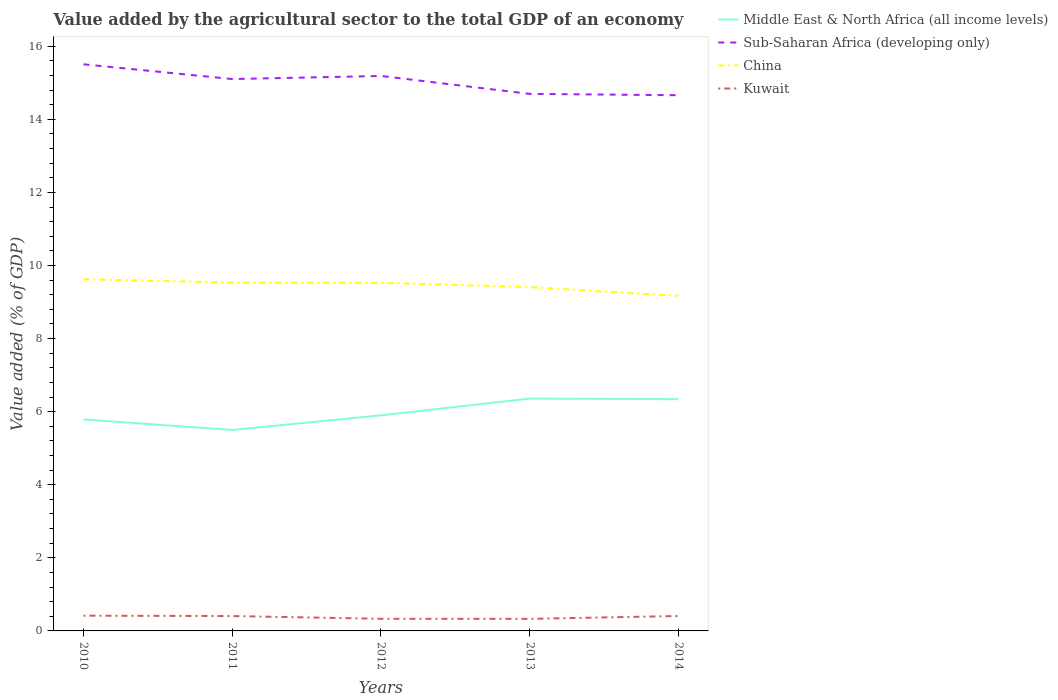Across all years, what is the maximum value added by the agricultural sector to the total GDP in Middle East & North Africa (all income levels)?
Your response must be concise. 5.5. In which year was the value added by the agricultural sector to the total GDP in Sub-Saharan Africa (developing only) maximum?
Make the answer very short. 2014. What is the total value added by the agricultural sector to the total GDP in China in the graph?
Your answer should be compact. 0.36. What is the difference between the highest and the second highest value added by the agricultural sector to the total GDP in Kuwait?
Your answer should be very brief. 0.09. What is the difference between two consecutive major ticks on the Y-axis?
Your answer should be compact. 2. Are the values on the major ticks of Y-axis written in scientific E-notation?
Give a very brief answer. No. How many legend labels are there?
Your answer should be compact. 4. What is the title of the graph?
Provide a succinct answer. Value added by the agricultural sector to the total GDP of an economy. Does "Middle East & North Africa (all income levels)" appear as one of the legend labels in the graph?
Ensure brevity in your answer.  Yes. What is the label or title of the Y-axis?
Make the answer very short. Value added (% of GDP). What is the Value added (% of GDP) of Middle East & North Africa (all income levels) in 2010?
Your answer should be compact. 5.79. What is the Value added (% of GDP) in Sub-Saharan Africa (developing only) in 2010?
Offer a very short reply. 15.51. What is the Value added (% of GDP) of China in 2010?
Offer a terse response. 9.62. What is the Value added (% of GDP) in Kuwait in 2010?
Give a very brief answer. 0.42. What is the Value added (% of GDP) of Middle East & North Africa (all income levels) in 2011?
Your answer should be very brief. 5.5. What is the Value added (% of GDP) of Sub-Saharan Africa (developing only) in 2011?
Offer a very short reply. 15.1. What is the Value added (% of GDP) in China in 2011?
Keep it short and to the point. 9.53. What is the Value added (% of GDP) of Kuwait in 2011?
Your response must be concise. 0.41. What is the Value added (% of GDP) of Middle East & North Africa (all income levels) in 2012?
Offer a terse response. 5.9. What is the Value added (% of GDP) of Sub-Saharan Africa (developing only) in 2012?
Provide a short and direct response. 15.19. What is the Value added (% of GDP) in China in 2012?
Your answer should be compact. 9.53. What is the Value added (% of GDP) of Kuwait in 2012?
Make the answer very short. 0.33. What is the Value added (% of GDP) in Middle East & North Africa (all income levels) in 2013?
Ensure brevity in your answer.  6.36. What is the Value added (% of GDP) in Sub-Saharan Africa (developing only) in 2013?
Provide a succinct answer. 14.7. What is the Value added (% of GDP) in China in 2013?
Your answer should be compact. 9.41. What is the Value added (% of GDP) in Kuwait in 2013?
Offer a very short reply. 0.33. What is the Value added (% of GDP) of Middle East & North Africa (all income levels) in 2014?
Provide a short and direct response. 6.34. What is the Value added (% of GDP) of Sub-Saharan Africa (developing only) in 2014?
Provide a succinct answer. 14.66. What is the Value added (% of GDP) of China in 2014?
Provide a short and direct response. 9.17. What is the Value added (% of GDP) in Kuwait in 2014?
Ensure brevity in your answer.  0.41. Across all years, what is the maximum Value added (% of GDP) in Middle East & North Africa (all income levels)?
Your answer should be very brief. 6.36. Across all years, what is the maximum Value added (% of GDP) in Sub-Saharan Africa (developing only)?
Give a very brief answer. 15.51. Across all years, what is the maximum Value added (% of GDP) of China?
Your answer should be very brief. 9.62. Across all years, what is the maximum Value added (% of GDP) in Kuwait?
Make the answer very short. 0.42. Across all years, what is the minimum Value added (% of GDP) of Middle East & North Africa (all income levels)?
Make the answer very short. 5.5. Across all years, what is the minimum Value added (% of GDP) of Sub-Saharan Africa (developing only)?
Your answer should be very brief. 14.66. Across all years, what is the minimum Value added (% of GDP) of China?
Offer a very short reply. 9.17. Across all years, what is the minimum Value added (% of GDP) in Kuwait?
Make the answer very short. 0.33. What is the total Value added (% of GDP) of Middle East & North Africa (all income levels) in the graph?
Give a very brief answer. 29.89. What is the total Value added (% of GDP) of Sub-Saharan Africa (developing only) in the graph?
Your response must be concise. 75.15. What is the total Value added (% of GDP) of China in the graph?
Give a very brief answer. 47.26. What is the total Value added (% of GDP) of Kuwait in the graph?
Provide a succinct answer. 1.89. What is the difference between the Value added (% of GDP) in Middle East & North Africa (all income levels) in 2010 and that in 2011?
Offer a terse response. 0.29. What is the difference between the Value added (% of GDP) in Sub-Saharan Africa (developing only) in 2010 and that in 2011?
Give a very brief answer. 0.4. What is the difference between the Value added (% of GDP) of China in 2010 and that in 2011?
Offer a terse response. 0.09. What is the difference between the Value added (% of GDP) of Kuwait in 2010 and that in 2011?
Your response must be concise. 0.01. What is the difference between the Value added (% of GDP) of Middle East & North Africa (all income levels) in 2010 and that in 2012?
Your answer should be compact. -0.11. What is the difference between the Value added (% of GDP) of Sub-Saharan Africa (developing only) in 2010 and that in 2012?
Keep it short and to the point. 0.32. What is the difference between the Value added (% of GDP) in China in 2010 and that in 2012?
Make the answer very short. 0.1. What is the difference between the Value added (% of GDP) of Kuwait in 2010 and that in 2012?
Your response must be concise. 0.09. What is the difference between the Value added (% of GDP) in Middle East & North Africa (all income levels) in 2010 and that in 2013?
Your response must be concise. -0.57. What is the difference between the Value added (% of GDP) of Sub-Saharan Africa (developing only) in 2010 and that in 2013?
Ensure brevity in your answer.  0.81. What is the difference between the Value added (% of GDP) in China in 2010 and that in 2013?
Give a very brief answer. 0.22. What is the difference between the Value added (% of GDP) of Kuwait in 2010 and that in 2013?
Make the answer very short. 0.09. What is the difference between the Value added (% of GDP) in Middle East & North Africa (all income levels) in 2010 and that in 2014?
Give a very brief answer. -0.55. What is the difference between the Value added (% of GDP) of Sub-Saharan Africa (developing only) in 2010 and that in 2014?
Your response must be concise. 0.85. What is the difference between the Value added (% of GDP) in China in 2010 and that in 2014?
Make the answer very short. 0.45. What is the difference between the Value added (% of GDP) in Kuwait in 2010 and that in 2014?
Give a very brief answer. 0.01. What is the difference between the Value added (% of GDP) in Middle East & North Africa (all income levels) in 2011 and that in 2012?
Provide a short and direct response. -0.4. What is the difference between the Value added (% of GDP) of Sub-Saharan Africa (developing only) in 2011 and that in 2012?
Offer a terse response. -0.08. What is the difference between the Value added (% of GDP) of China in 2011 and that in 2012?
Give a very brief answer. 0.01. What is the difference between the Value added (% of GDP) in Kuwait in 2011 and that in 2012?
Your response must be concise. 0.07. What is the difference between the Value added (% of GDP) of Middle East & North Africa (all income levels) in 2011 and that in 2013?
Provide a short and direct response. -0.86. What is the difference between the Value added (% of GDP) of Sub-Saharan Africa (developing only) in 2011 and that in 2013?
Keep it short and to the point. 0.41. What is the difference between the Value added (% of GDP) of China in 2011 and that in 2013?
Your answer should be very brief. 0.13. What is the difference between the Value added (% of GDP) in Kuwait in 2011 and that in 2013?
Your answer should be very brief. 0.08. What is the difference between the Value added (% of GDP) of Middle East & North Africa (all income levels) in 2011 and that in 2014?
Your answer should be compact. -0.84. What is the difference between the Value added (% of GDP) in Sub-Saharan Africa (developing only) in 2011 and that in 2014?
Offer a terse response. 0.44. What is the difference between the Value added (% of GDP) in China in 2011 and that in 2014?
Provide a short and direct response. 0.36. What is the difference between the Value added (% of GDP) in Kuwait in 2011 and that in 2014?
Ensure brevity in your answer.  -0. What is the difference between the Value added (% of GDP) of Middle East & North Africa (all income levels) in 2012 and that in 2013?
Keep it short and to the point. -0.46. What is the difference between the Value added (% of GDP) of Sub-Saharan Africa (developing only) in 2012 and that in 2013?
Your response must be concise. 0.49. What is the difference between the Value added (% of GDP) in China in 2012 and that in 2013?
Your answer should be compact. 0.12. What is the difference between the Value added (% of GDP) of Kuwait in 2012 and that in 2013?
Provide a short and direct response. 0. What is the difference between the Value added (% of GDP) of Middle East & North Africa (all income levels) in 2012 and that in 2014?
Offer a terse response. -0.44. What is the difference between the Value added (% of GDP) of Sub-Saharan Africa (developing only) in 2012 and that in 2014?
Provide a succinct answer. 0.53. What is the difference between the Value added (% of GDP) in China in 2012 and that in 2014?
Offer a terse response. 0.36. What is the difference between the Value added (% of GDP) of Kuwait in 2012 and that in 2014?
Keep it short and to the point. -0.08. What is the difference between the Value added (% of GDP) of Middle East & North Africa (all income levels) in 2013 and that in 2014?
Keep it short and to the point. 0.02. What is the difference between the Value added (% of GDP) in Sub-Saharan Africa (developing only) in 2013 and that in 2014?
Your answer should be compact. 0.04. What is the difference between the Value added (% of GDP) of China in 2013 and that in 2014?
Your answer should be very brief. 0.24. What is the difference between the Value added (% of GDP) in Kuwait in 2013 and that in 2014?
Your answer should be very brief. -0.08. What is the difference between the Value added (% of GDP) in Middle East & North Africa (all income levels) in 2010 and the Value added (% of GDP) in Sub-Saharan Africa (developing only) in 2011?
Offer a very short reply. -9.32. What is the difference between the Value added (% of GDP) in Middle East & North Africa (all income levels) in 2010 and the Value added (% of GDP) in China in 2011?
Make the answer very short. -3.75. What is the difference between the Value added (% of GDP) of Middle East & North Africa (all income levels) in 2010 and the Value added (% of GDP) of Kuwait in 2011?
Make the answer very short. 5.38. What is the difference between the Value added (% of GDP) in Sub-Saharan Africa (developing only) in 2010 and the Value added (% of GDP) in China in 2011?
Ensure brevity in your answer.  5.97. What is the difference between the Value added (% of GDP) of Sub-Saharan Africa (developing only) in 2010 and the Value added (% of GDP) of Kuwait in 2011?
Your answer should be very brief. 15.1. What is the difference between the Value added (% of GDP) in China in 2010 and the Value added (% of GDP) in Kuwait in 2011?
Your answer should be compact. 9.22. What is the difference between the Value added (% of GDP) in Middle East & North Africa (all income levels) in 2010 and the Value added (% of GDP) in Sub-Saharan Africa (developing only) in 2012?
Offer a terse response. -9.4. What is the difference between the Value added (% of GDP) of Middle East & North Africa (all income levels) in 2010 and the Value added (% of GDP) of China in 2012?
Ensure brevity in your answer.  -3.74. What is the difference between the Value added (% of GDP) of Middle East & North Africa (all income levels) in 2010 and the Value added (% of GDP) of Kuwait in 2012?
Your response must be concise. 5.46. What is the difference between the Value added (% of GDP) in Sub-Saharan Africa (developing only) in 2010 and the Value added (% of GDP) in China in 2012?
Keep it short and to the point. 5.98. What is the difference between the Value added (% of GDP) of Sub-Saharan Africa (developing only) in 2010 and the Value added (% of GDP) of Kuwait in 2012?
Your answer should be compact. 15.17. What is the difference between the Value added (% of GDP) in China in 2010 and the Value added (% of GDP) in Kuwait in 2012?
Provide a short and direct response. 9.29. What is the difference between the Value added (% of GDP) in Middle East & North Africa (all income levels) in 2010 and the Value added (% of GDP) in Sub-Saharan Africa (developing only) in 2013?
Your answer should be compact. -8.91. What is the difference between the Value added (% of GDP) of Middle East & North Africa (all income levels) in 2010 and the Value added (% of GDP) of China in 2013?
Give a very brief answer. -3.62. What is the difference between the Value added (% of GDP) of Middle East & North Africa (all income levels) in 2010 and the Value added (% of GDP) of Kuwait in 2013?
Give a very brief answer. 5.46. What is the difference between the Value added (% of GDP) of Sub-Saharan Africa (developing only) in 2010 and the Value added (% of GDP) of China in 2013?
Your answer should be very brief. 6.1. What is the difference between the Value added (% of GDP) in Sub-Saharan Africa (developing only) in 2010 and the Value added (% of GDP) in Kuwait in 2013?
Keep it short and to the point. 15.18. What is the difference between the Value added (% of GDP) of China in 2010 and the Value added (% of GDP) of Kuwait in 2013?
Offer a terse response. 9.29. What is the difference between the Value added (% of GDP) in Middle East & North Africa (all income levels) in 2010 and the Value added (% of GDP) in Sub-Saharan Africa (developing only) in 2014?
Offer a terse response. -8.87. What is the difference between the Value added (% of GDP) in Middle East & North Africa (all income levels) in 2010 and the Value added (% of GDP) in China in 2014?
Give a very brief answer. -3.38. What is the difference between the Value added (% of GDP) of Middle East & North Africa (all income levels) in 2010 and the Value added (% of GDP) of Kuwait in 2014?
Provide a succinct answer. 5.38. What is the difference between the Value added (% of GDP) in Sub-Saharan Africa (developing only) in 2010 and the Value added (% of GDP) in China in 2014?
Offer a terse response. 6.34. What is the difference between the Value added (% of GDP) in Sub-Saharan Africa (developing only) in 2010 and the Value added (% of GDP) in Kuwait in 2014?
Offer a very short reply. 15.1. What is the difference between the Value added (% of GDP) of China in 2010 and the Value added (% of GDP) of Kuwait in 2014?
Ensure brevity in your answer.  9.22. What is the difference between the Value added (% of GDP) in Middle East & North Africa (all income levels) in 2011 and the Value added (% of GDP) in Sub-Saharan Africa (developing only) in 2012?
Keep it short and to the point. -9.69. What is the difference between the Value added (% of GDP) of Middle East & North Africa (all income levels) in 2011 and the Value added (% of GDP) of China in 2012?
Give a very brief answer. -4.03. What is the difference between the Value added (% of GDP) of Middle East & North Africa (all income levels) in 2011 and the Value added (% of GDP) of Kuwait in 2012?
Provide a short and direct response. 5.17. What is the difference between the Value added (% of GDP) in Sub-Saharan Africa (developing only) in 2011 and the Value added (% of GDP) in China in 2012?
Make the answer very short. 5.57. What is the difference between the Value added (% of GDP) in Sub-Saharan Africa (developing only) in 2011 and the Value added (% of GDP) in Kuwait in 2012?
Your answer should be very brief. 14.77. What is the difference between the Value added (% of GDP) of China in 2011 and the Value added (% of GDP) of Kuwait in 2012?
Make the answer very short. 9.2. What is the difference between the Value added (% of GDP) of Middle East & North Africa (all income levels) in 2011 and the Value added (% of GDP) of Sub-Saharan Africa (developing only) in 2013?
Your response must be concise. -9.2. What is the difference between the Value added (% of GDP) in Middle East & North Africa (all income levels) in 2011 and the Value added (% of GDP) in China in 2013?
Keep it short and to the point. -3.91. What is the difference between the Value added (% of GDP) in Middle East & North Africa (all income levels) in 2011 and the Value added (% of GDP) in Kuwait in 2013?
Provide a succinct answer. 5.17. What is the difference between the Value added (% of GDP) in Sub-Saharan Africa (developing only) in 2011 and the Value added (% of GDP) in China in 2013?
Make the answer very short. 5.69. What is the difference between the Value added (% of GDP) of Sub-Saharan Africa (developing only) in 2011 and the Value added (% of GDP) of Kuwait in 2013?
Your response must be concise. 14.77. What is the difference between the Value added (% of GDP) in China in 2011 and the Value added (% of GDP) in Kuwait in 2013?
Your answer should be compact. 9.2. What is the difference between the Value added (% of GDP) in Middle East & North Africa (all income levels) in 2011 and the Value added (% of GDP) in Sub-Saharan Africa (developing only) in 2014?
Your answer should be compact. -9.16. What is the difference between the Value added (% of GDP) in Middle East & North Africa (all income levels) in 2011 and the Value added (% of GDP) in China in 2014?
Keep it short and to the point. -3.67. What is the difference between the Value added (% of GDP) in Middle East & North Africa (all income levels) in 2011 and the Value added (% of GDP) in Kuwait in 2014?
Keep it short and to the point. 5.09. What is the difference between the Value added (% of GDP) of Sub-Saharan Africa (developing only) in 2011 and the Value added (% of GDP) of China in 2014?
Provide a short and direct response. 5.93. What is the difference between the Value added (% of GDP) of Sub-Saharan Africa (developing only) in 2011 and the Value added (% of GDP) of Kuwait in 2014?
Your response must be concise. 14.69. What is the difference between the Value added (% of GDP) in China in 2011 and the Value added (% of GDP) in Kuwait in 2014?
Offer a very short reply. 9.13. What is the difference between the Value added (% of GDP) of Middle East & North Africa (all income levels) in 2012 and the Value added (% of GDP) of Sub-Saharan Africa (developing only) in 2013?
Provide a short and direct response. -8.8. What is the difference between the Value added (% of GDP) of Middle East & North Africa (all income levels) in 2012 and the Value added (% of GDP) of China in 2013?
Your answer should be very brief. -3.51. What is the difference between the Value added (% of GDP) of Middle East & North Africa (all income levels) in 2012 and the Value added (% of GDP) of Kuwait in 2013?
Your answer should be very brief. 5.57. What is the difference between the Value added (% of GDP) in Sub-Saharan Africa (developing only) in 2012 and the Value added (% of GDP) in China in 2013?
Keep it short and to the point. 5.78. What is the difference between the Value added (% of GDP) of Sub-Saharan Africa (developing only) in 2012 and the Value added (% of GDP) of Kuwait in 2013?
Provide a succinct answer. 14.86. What is the difference between the Value added (% of GDP) in China in 2012 and the Value added (% of GDP) in Kuwait in 2013?
Your answer should be compact. 9.2. What is the difference between the Value added (% of GDP) of Middle East & North Africa (all income levels) in 2012 and the Value added (% of GDP) of Sub-Saharan Africa (developing only) in 2014?
Ensure brevity in your answer.  -8.76. What is the difference between the Value added (% of GDP) in Middle East & North Africa (all income levels) in 2012 and the Value added (% of GDP) in China in 2014?
Offer a very short reply. -3.27. What is the difference between the Value added (% of GDP) of Middle East & North Africa (all income levels) in 2012 and the Value added (% of GDP) of Kuwait in 2014?
Provide a succinct answer. 5.49. What is the difference between the Value added (% of GDP) of Sub-Saharan Africa (developing only) in 2012 and the Value added (% of GDP) of China in 2014?
Keep it short and to the point. 6.02. What is the difference between the Value added (% of GDP) of Sub-Saharan Africa (developing only) in 2012 and the Value added (% of GDP) of Kuwait in 2014?
Your answer should be compact. 14.78. What is the difference between the Value added (% of GDP) of China in 2012 and the Value added (% of GDP) of Kuwait in 2014?
Keep it short and to the point. 9.12. What is the difference between the Value added (% of GDP) of Middle East & North Africa (all income levels) in 2013 and the Value added (% of GDP) of Sub-Saharan Africa (developing only) in 2014?
Your answer should be very brief. -8.3. What is the difference between the Value added (% of GDP) of Middle East & North Africa (all income levels) in 2013 and the Value added (% of GDP) of China in 2014?
Provide a succinct answer. -2.81. What is the difference between the Value added (% of GDP) of Middle East & North Africa (all income levels) in 2013 and the Value added (% of GDP) of Kuwait in 2014?
Your answer should be compact. 5.95. What is the difference between the Value added (% of GDP) in Sub-Saharan Africa (developing only) in 2013 and the Value added (% of GDP) in China in 2014?
Give a very brief answer. 5.53. What is the difference between the Value added (% of GDP) of Sub-Saharan Africa (developing only) in 2013 and the Value added (% of GDP) of Kuwait in 2014?
Provide a succinct answer. 14.29. What is the difference between the Value added (% of GDP) in China in 2013 and the Value added (% of GDP) in Kuwait in 2014?
Provide a short and direct response. 9. What is the average Value added (% of GDP) in Middle East & North Africa (all income levels) per year?
Offer a terse response. 5.98. What is the average Value added (% of GDP) in Sub-Saharan Africa (developing only) per year?
Keep it short and to the point. 15.03. What is the average Value added (% of GDP) of China per year?
Give a very brief answer. 9.45. What is the average Value added (% of GDP) of Kuwait per year?
Keep it short and to the point. 0.38. In the year 2010, what is the difference between the Value added (% of GDP) in Middle East & North Africa (all income levels) and Value added (% of GDP) in Sub-Saharan Africa (developing only)?
Your answer should be very brief. -9.72. In the year 2010, what is the difference between the Value added (% of GDP) in Middle East & North Africa (all income levels) and Value added (% of GDP) in China?
Ensure brevity in your answer.  -3.84. In the year 2010, what is the difference between the Value added (% of GDP) in Middle East & North Africa (all income levels) and Value added (% of GDP) in Kuwait?
Keep it short and to the point. 5.37. In the year 2010, what is the difference between the Value added (% of GDP) in Sub-Saharan Africa (developing only) and Value added (% of GDP) in China?
Offer a very short reply. 5.88. In the year 2010, what is the difference between the Value added (% of GDP) of Sub-Saharan Africa (developing only) and Value added (% of GDP) of Kuwait?
Give a very brief answer. 15.09. In the year 2010, what is the difference between the Value added (% of GDP) in China and Value added (% of GDP) in Kuwait?
Ensure brevity in your answer.  9.21. In the year 2011, what is the difference between the Value added (% of GDP) in Middle East & North Africa (all income levels) and Value added (% of GDP) in Sub-Saharan Africa (developing only)?
Provide a succinct answer. -9.6. In the year 2011, what is the difference between the Value added (% of GDP) in Middle East & North Africa (all income levels) and Value added (% of GDP) in China?
Your answer should be very brief. -4.03. In the year 2011, what is the difference between the Value added (% of GDP) in Middle East & North Africa (all income levels) and Value added (% of GDP) in Kuwait?
Your response must be concise. 5.09. In the year 2011, what is the difference between the Value added (% of GDP) in Sub-Saharan Africa (developing only) and Value added (% of GDP) in China?
Ensure brevity in your answer.  5.57. In the year 2011, what is the difference between the Value added (% of GDP) in Sub-Saharan Africa (developing only) and Value added (% of GDP) in Kuwait?
Provide a short and direct response. 14.7. In the year 2011, what is the difference between the Value added (% of GDP) in China and Value added (% of GDP) in Kuwait?
Your answer should be compact. 9.13. In the year 2012, what is the difference between the Value added (% of GDP) in Middle East & North Africa (all income levels) and Value added (% of GDP) in Sub-Saharan Africa (developing only)?
Ensure brevity in your answer.  -9.29. In the year 2012, what is the difference between the Value added (% of GDP) in Middle East & North Africa (all income levels) and Value added (% of GDP) in China?
Keep it short and to the point. -3.63. In the year 2012, what is the difference between the Value added (% of GDP) in Middle East & North Africa (all income levels) and Value added (% of GDP) in Kuwait?
Your response must be concise. 5.57. In the year 2012, what is the difference between the Value added (% of GDP) of Sub-Saharan Africa (developing only) and Value added (% of GDP) of China?
Provide a short and direct response. 5.66. In the year 2012, what is the difference between the Value added (% of GDP) of Sub-Saharan Africa (developing only) and Value added (% of GDP) of Kuwait?
Keep it short and to the point. 14.86. In the year 2012, what is the difference between the Value added (% of GDP) of China and Value added (% of GDP) of Kuwait?
Your answer should be very brief. 9.2. In the year 2013, what is the difference between the Value added (% of GDP) of Middle East & North Africa (all income levels) and Value added (% of GDP) of Sub-Saharan Africa (developing only)?
Give a very brief answer. -8.34. In the year 2013, what is the difference between the Value added (% of GDP) of Middle East & North Africa (all income levels) and Value added (% of GDP) of China?
Give a very brief answer. -3.05. In the year 2013, what is the difference between the Value added (% of GDP) of Middle East & North Africa (all income levels) and Value added (% of GDP) of Kuwait?
Offer a very short reply. 6.03. In the year 2013, what is the difference between the Value added (% of GDP) of Sub-Saharan Africa (developing only) and Value added (% of GDP) of China?
Provide a succinct answer. 5.29. In the year 2013, what is the difference between the Value added (% of GDP) of Sub-Saharan Africa (developing only) and Value added (% of GDP) of Kuwait?
Offer a very short reply. 14.37. In the year 2013, what is the difference between the Value added (% of GDP) in China and Value added (% of GDP) in Kuwait?
Make the answer very short. 9.08. In the year 2014, what is the difference between the Value added (% of GDP) in Middle East & North Africa (all income levels) and Value added (% of GDP) in Sub-Saharan Africa (developing only)?
Offer a very short reply. -8.32. In the year 2014, what is the difference between the Value added (% of GDP) in Middle East & North Africa (all income levels) and Value added (% of GDP) in China?
Your answer should be very brief. -2.83. In the year 2014, what is the difference between the Value added (% of GDP) in Middle East & North Africa (all income levels) and Value added (% of GDP) in Kuwait?
Provide a short and direct response. 5.93. In the year 2014, what is the difference between the Value added (% of GDP) in Sub-Saharan Africa (developing only) and Value added (% of GDP) in China?
Provide a succinct answer. 5.49. In the year 2014, what is the difference between the Value added (% of GDP) in Sub-Saharan Africa (developing only) and Value added (% of GDP) in Kuwait?
Provide a short and direct response. 14.25. In the year 2014, what is the difference between the Value added (% of GDP) in China and Value added (% of GDP) in Kuwait?
Provide a succinct answer. 8.76. What is the ratio of the Value added (% of GDP) in Middle East & North Africa (all income levels) in 2010 to that in 2011?
Your response must be concise. 1.05. What is the ratio of the Value added (% of GDP) in Sub-Saharan Africa (developing only) in 2010 to that in 2011?
Your answer should be compact. 1.03. What is the ratio of the Value added (% of GDP) in China in 2010 to that in 2011?
Your answer should be compact. 1.01. What is the ratio of the Value added (% of GDP) in Kuwait in 2010 to that in 2011?
Your response must be concise. 1.03. What is the ratio of the Value added (% of GDP) in Middle East & North Africa (all income levels) in 2010 to that in 2012?
Your answer should be very brief. 0.98. What is the ratio of the Value added (% of GDP) of Sub-Saharan Africa (developing only) in 2010 to that in 2012?
Your answer should be very brief. 1.02. What is the ratio of the Value added (% of GDP) of Kuwait in 2010 to that in 2012?
Provide a succinct answer. 1.26. What is the ratio of the Value added (% of GDP) of Middle East & North Africa (all income levels) in 2010 to that in 2013?
Ensure brevity in your answer.  0.91. What is the ratio of the Value added (% of GDP) in Sub-Saharan Africa (developing only) in 2010 to that in 2013?
Ensure brevity in your answer.  1.06. What is the ratio of the Value added (% of GDP) in China in 2010 to that in 2013?
Your answer should be compact. 1.02. What is the ratio of the Value added (% of GDP) in Kuwait in 2010 to that in 2013?
Keep it short and to the point. 1.26. What is the ratio of the Value added (% of GDP) in Middle East & North Africa (all income levels) in 2010 to that in 2014?
Offer a very short reply. 0.91. What is the ratio of the Value added (% of GDP) of Sub-Saharan Africa (developing only) in 2010 to that in 2014?
Make the answer very short. 1.06. What is the ratio of the Value added (% of GDP) in China in 2010 to that in 2014?
Offer a terse response. 1.05. What is the ratio of the Value added (% of GDP) in Kuwait in 2010 to that in 2014?
Your response must be concise. 1.02. What is the ratio of the Value added (% of GDP) of Middle East & North Africa (all income levels) in 2011 to that in 2012?
Your answer should be very brief. 0.93. What is the ratio of the Value added (% of GDP) of China in 2011 to that in 2012?
Provide a short and direct response. 1. What is the ratio of the Value added (% of GDP) in Kuwait in 2011 to that in 2012?
Keep it short and to the point. 1.22. What is the ratio of the Value added (% of GDP) of Middle East & North Africa (all income levels) in 2011 to that in 2013?
Keep it short and to the point. 0.86. What is the ratio of the Value added (% of GDP) in Sub-Saharan Africa (developing only) in 2011 to that in 2013?
Offer a terse response. 1.03. What is the ratio of the Value added (% of GDP) of China in 2011 to that in 2013?
Provide a short and direct response. 1.01. What is the ratio of the Value added (% of GDP) of Kuwait in 2011 to that in 2013?
Make the answer very short. 1.23. What is the ratio of the Value added (% of GDP) in Middle East & North Africa (all income levels) in 2011 to that in 2014?
Offer a very short reply. 0.87. What is the ratio of the Value added (% of GDP) in Sub-Saharan Africa (developing only) in 2011 to that in 2014?
Provide a short and direct response. 1.03. What is the ratio of the Value added (% of GDP) in China in 2011 to that in 2014?
Keep it short and to the point. 1.04. What is the ratio of the Value added (% of GDP) of Middle East & North Africa (all income levels) in 2012 to that in 2013?
Make the answer very short. 0.93. What is the ratio of the Value added (% of GDP) in Sub-Saharan Africa (developing only) in 2012 to that in 2013?
Your answer should be compact. 1.03. What is the ratio of the Value added (% of GDP) in China in 2012 to that in 2013?
Offer a terse response. 1.01. What is the ratio of the Value added (% of GDP) of Middle East & North Africa (all income levels) in 2012 to that in 2014?
Ensure brevity in your answer.  0.93. What is the ratio of the Value added (% of GDP) in Sub-Saharan Africa (developing only) in 2012 to that in 2014?
Keep it short and to the point. 1.04. What is the ratio of the Value added (% of GDP) of China in 2012 to that in 2014?
Your answer should be very brief. 1.04. What is the ratio of the Value added (% of GDP) in Kuwait in 2012 to that in 2014?
Give a very brief answer. 0.81. What is the ratio of the Value added (% of GDP) of Sub-Saharan Africa (developing only) in 2013 to that in 2014?
Your response must be concise. 1. What is the ratio of the Value added (% of GDP) of China in 2013 to that in 2014?
Your answer should be very brief. 1.03. What is the ratio of the Value added (% of GDP) of Kuwait in 2013 to that in 2014?
Provide a short and direct response. 0.81. What is the difference between the highest and the second highest Value added (% of GDP) in Middle East & North Africa (all income levels)?
Ensure brevity in your answer.  0.02. What is the difference between the highest and the second highest Value added (% of GDP) of Sub-Saharan Africa (developing only)?
Offer a very short reply. 0.32. What is the difference between the highest and the second highest Value added (% of GDP) of China?
Provide a succinct answer. 0.09. What is the difference between the highest and the second highest Value added (% of GDP) in Kuwait?
Provide a short and direct response. 0.01. What is the difference between the highest and the lowest Value added (% of GDP) in Middle East & North Africa (all income levels)?
Give a very brief answer. 0.86. What is the difference between the highest and the lowest Value added (% of GDP) in Sub-Saharan Africa (developing only)?
Ensure brevity in your answer.  0.85. What is the difference between the highest and the lowest Value added (% of GDP) of China?
Provide a short and direct response. 0.45. What is the difference between the highest and the lowest Value added (% of GDP) of Kuwait?
Offer a very short reply. 0.09. 